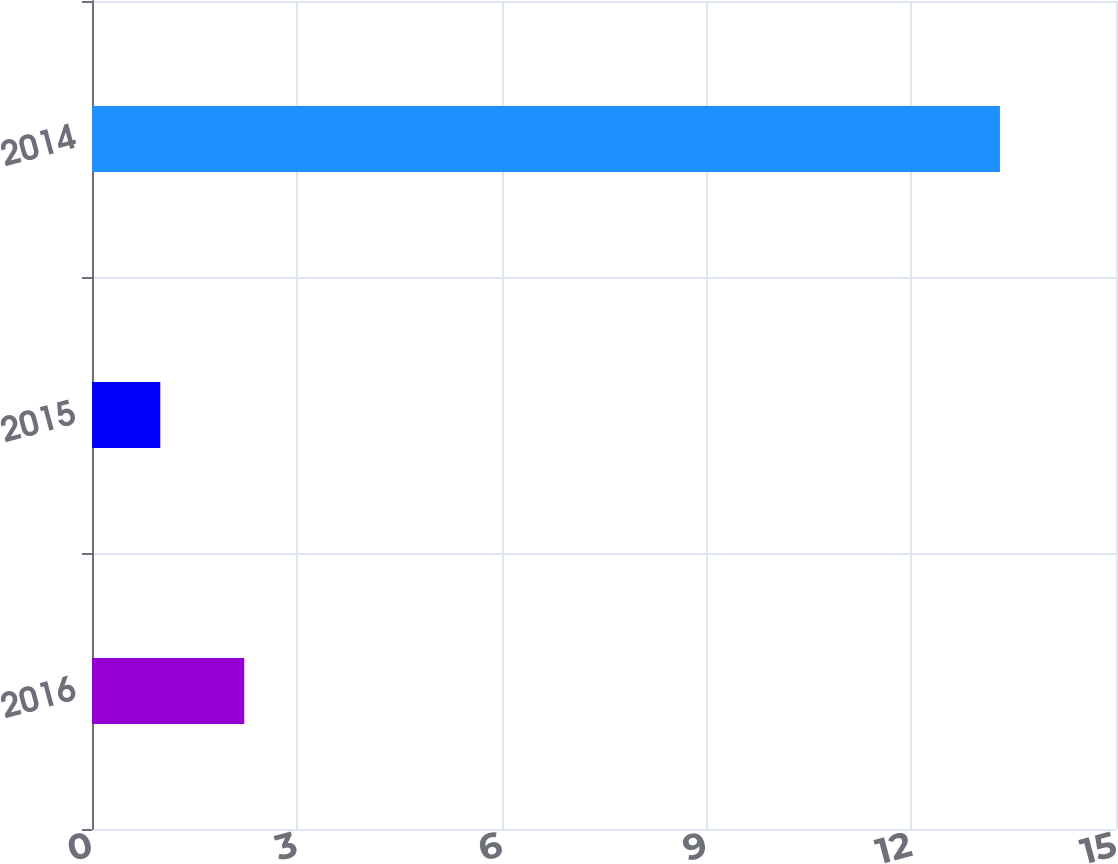Convert chart. <chart><loc_0><loc_0><loc_500><loc_500><bar_chart><fcel>2016<fcel>2015<fcel>2014<nl><fcel>2.23<fcel>1<fcel>13.3<nl></chart> 